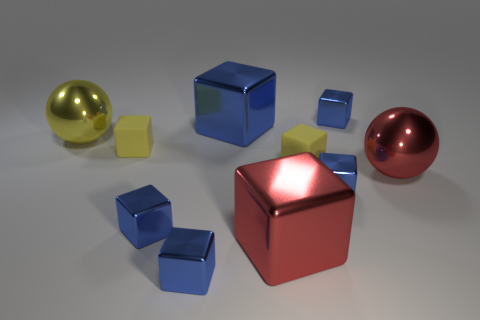What material is the tiny yellow cube that is right of the small rubber block that is to the left of the large metallic block behind the large yellow shiny ball?
Make the answer very short. Rubber. What number of large things are yellow matte blocks or yellow cylinders?
Keep it short and to the point. 0. Does the yellow ball that is left of the big red ball have the same material as the tiny yellow cube that is right of the red cube?
Your answer should be compact. No. Are any tiny cubes visible?
Your answer should be very brief. Yes. Is the number of small cubes on the left side of the red sphere greater than the number of big blue metal cubes in front of the big yellow thing?
Give a very brief answer. Yes. There is another big object that is the same shape as the large blue metal thing; what is it made of?
Keep it short and to the point. Metal. Do the metal ball that is in front of the large yellow metallic object and the big metal block that is in front of the big yellow sphere have the same color?
Your answer should be very brief. Yes. The yellow metallic thing has what shape?
Provide a short and direct response. Sphere. Are there more small shiny things that are in front of the large blue cube than red balls?
Offer a terse response. Yes. There is a tiny yellow matte thing to the left of the big blue block; what shape is it?
Make the answer very short. Cube. 